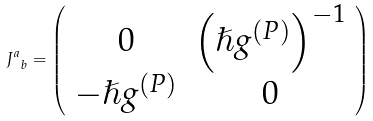<formula> <loc_0><loc_0><loc_500><loc_500>J _ { \ b } ^ { a } = \left ( \begin{array} { c c } 0 & \left ( \hslash g ^ { ( P ) } \right ) ^ { - 1 } \\ - \hslash g ^ { ( P ) } & 0 \end{array} \right )</formula> 